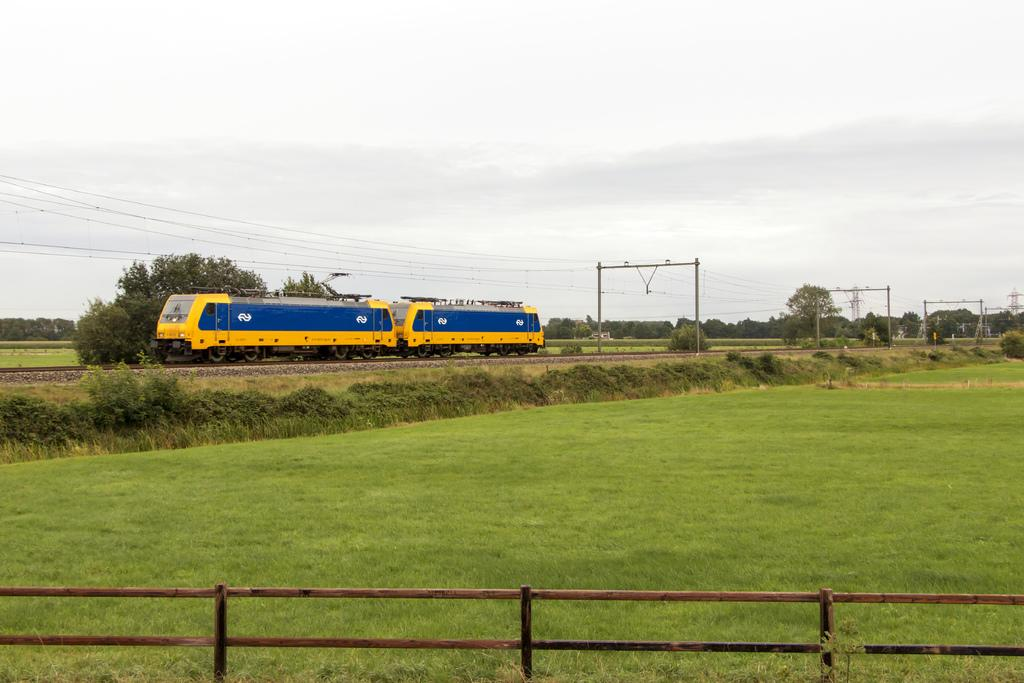What is the main subject of the image? The main subject of the image is a train on the railway track. What type of vegetation can be seen in the image? Grass, plants, and trees are visible in the image. What other objects can be seen in the image? Stones, poles, and cables are present in the image. What is visible in the sky in the image? The sky is visible in the image, and clouds are present. What type of soap is being used by the fireman in the image? There is no fireman or soap present in the image; it features a train on a railway track with various natural and man-made elements. 